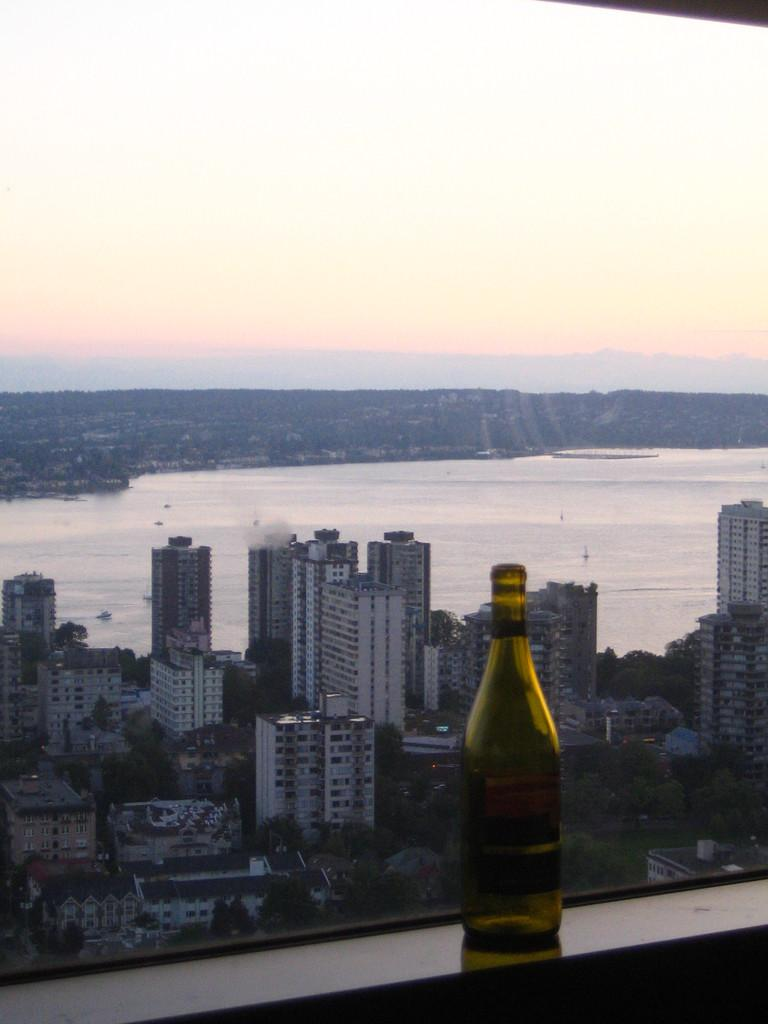What is visible at the top of the image? The sky is visible at the top of the image. What type of structures can be seen in the image? There are buildings in the image. Can you describe an object that is in front of the picture? There is a bottle in front of the picture. What type of apple is being served for dinner in the image? There is no apple or dinner present in the image; it only features the sky, buildings, and a bottle. How does the bottle burst in the image? The bottle does not burst in the image; it is stationary and intact. 